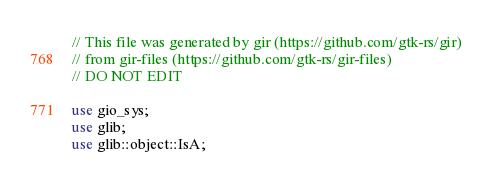<code> <loc_0><loc_0><loc_500><loc_500><_Rust_>// This file was generated by gir (https://github.com/gtk-rs/gir)
// from gir-files (https://github.com/gtk-rs/gir-files)
// DO NOT EDIT

use gio_sys;
use glib;
use glib::object::IsA;</code> 